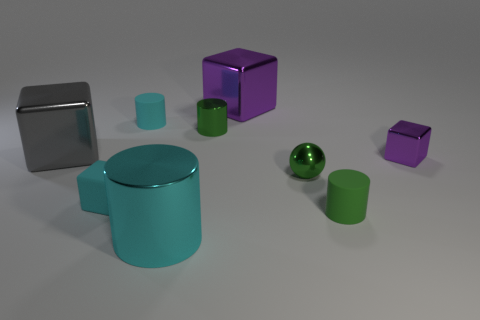Add 1 cyan things. How many objects exist? 10 Subtract all cylinders. How many objects are left? 5 Add 7 small gray shiny spheres. How many small gray shiny spheres exist? 7 Subtract 0 yellow blocks. How many objects are left? 9 Subtract all small rubber things. Subtract all small green metal cylinders. How many objects are left? 5 Add 7 small green things. How many small green things are left? 10 